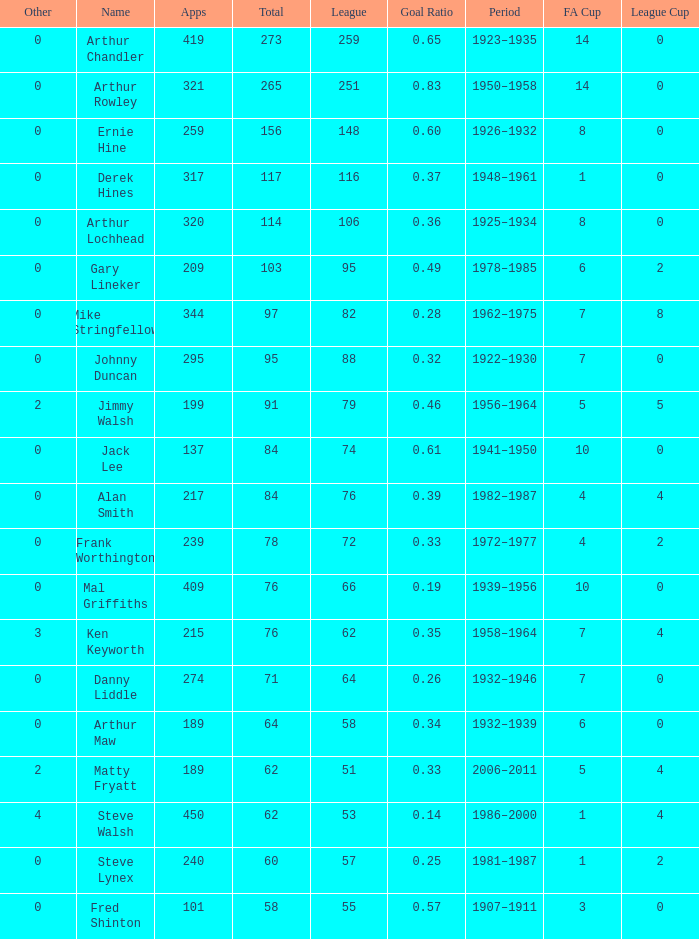What's the highest FA Cup with the Name of Alan Smith, and League Cup smaller than 4? None. 